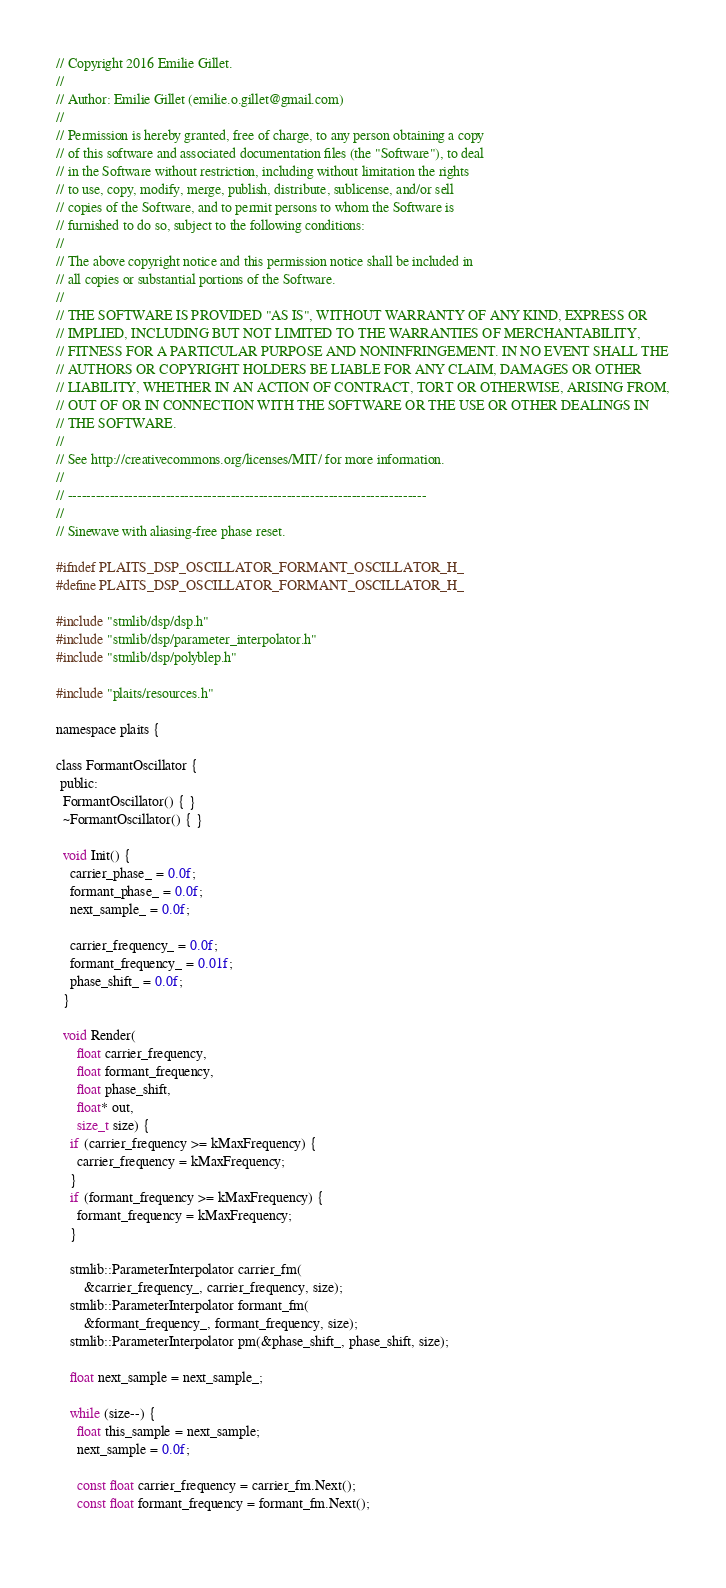<code> <loc_0><loc_0><loc_500><loc_500><_C_>// Copyright 2016 Emilie Gillet.
//
// Author: Emilie Gillet (emilie.o.gillet@gmail.com)
//
// Permission is hereby granted, free of charge, to any person obtaining a copy
// of this software and associated documentation files (the "Software"), to deal
// in the Software without restriction, including without limitation the rights
// to use, copy, modify, merge, publish, distribute, sublicense, and/or sell
// copies of the Software, and to permit persons to whom the Software is
// furnished to do so, subject to the following conditions:
// 
// The above copyright notice and this permission notice shall be included in
// all copies or substantial portions of the Software.
// 
// THE SOFTWARE IS PROVIDED "AS IS", WITHOUT WARRANTY OF ANY KIND, EXPRESS OR
// IMPLIED, INCLUDING BUT NOT LIMITED TO THE WARRANTIES OF MERCHANTABILITY,
// FITNESS FOR A PARTICULAR PURPOSE AND NONINFRINGEMENT. IN NO EVENT SHALL THE
// AUTHORS OR COPYRIGHT HOLDERS BE LIABLE FOR ANY CLAIM, DAMAGES OR OTHER
// LIABILITY, WHETHER IN AN ACTION OF CONTRACT, TORT OR OTHERWISE, ARISING FROM,
// OUT OF OR IN CONNECTION WITH THE SOFTWARE OR THE USE OR OTHER DEALINGS IN
// THE SOFTWARE.
// 
// See http://creativecommons.org/licenses/MIT/ for more information.
//
// -----------------------------------------------------------------------------
//
// Sinewave with aliasing-free phase reset.

#ifndef PLAITS_DSP_OSCILLATOR_FORMANT_OSCILLATOR_H_
#define PLAITS_DSP_OSCILLATOR_FORMANT_OSCILLATOR_H_

#include "stmlib/dsp/dsp.h"
#include "stmlib/dsp/parameter_interpolator.h"
#include "stmlib/dsp/polyblep.h"

#include "plaits/resources.h"

namespace plaits {

class FormantOscillator {
 public:
  FormantOscillator() { }
  ~FormantOscillator() { }

  void Init() {
    carrier_phase_ = 0.0f;
    formant_phase_ = 0.0f;
    next_sample_ = 0.0f;
  
    carrier_frequency_ = 0.0f;
    formant_frequency_ = 0.01f;
    phase_shift_ = 0.0f;
  }
  
  void Render(
      float carrier_frequency,
      float formant_frequency,
      float phase_shift,
      float* out,
      size_t size) {
    if (carrier_frequency >= kMaxFrequency) {
      carrier_frequency = kMaxFrequency;
    }
    if (formant_frequency >= kMaxFrequency) {
      formant_frequency = kMaxFrequency;
    }

    stmlib::ParameterInterpolator carrier_fm(
        &carrier_frequency_, carrier_frequency, size);
    stmlib::ParameterInterpolator formant_fm(
        &formant_frequency_, formant_frequency, size);
    stmlib::ParameterInterpolator pm(&phase_shift_, phase_shift, size);

    float next_sample = next_sample_;
    
    while (size--) {
      float this_sample = next_sample;
      next_sample = 0.0f;
    
      const float carrier_frequency = carrier_fm.Next();
      const float formant_frequency = formant_fm.Next();
    </code> 